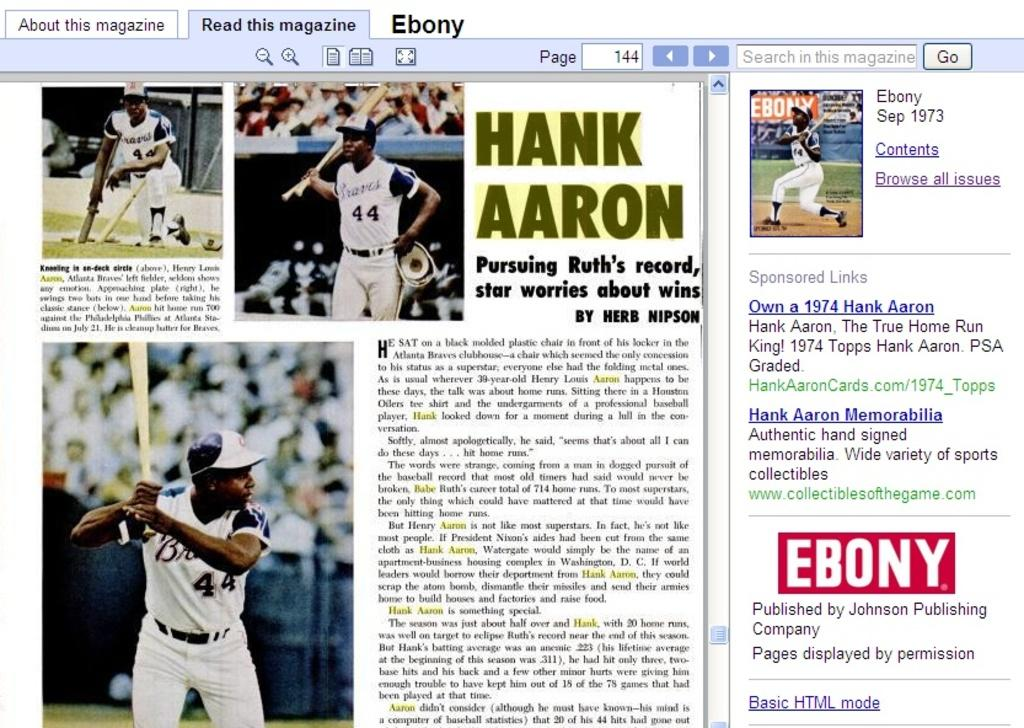<image>
Write a terse but informative summary of the picture. webpage for ebony magazine showing photos and article on hank aaron 